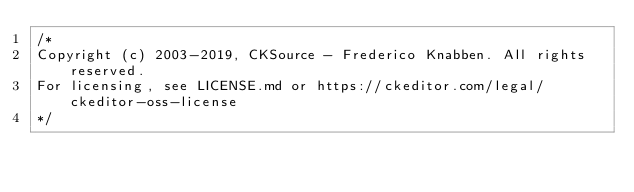Convert code to text. <code><loc_0><loc_0><loc_500><loc_500><_CSS_>/*
Copyright (c) 2003-2019, CKSource - Frederico Knabben. All rights reserved.
For licensing, see LICENSE.md or https://ckeditor.com/legal/ckeditor-oss-license
*/</code> 